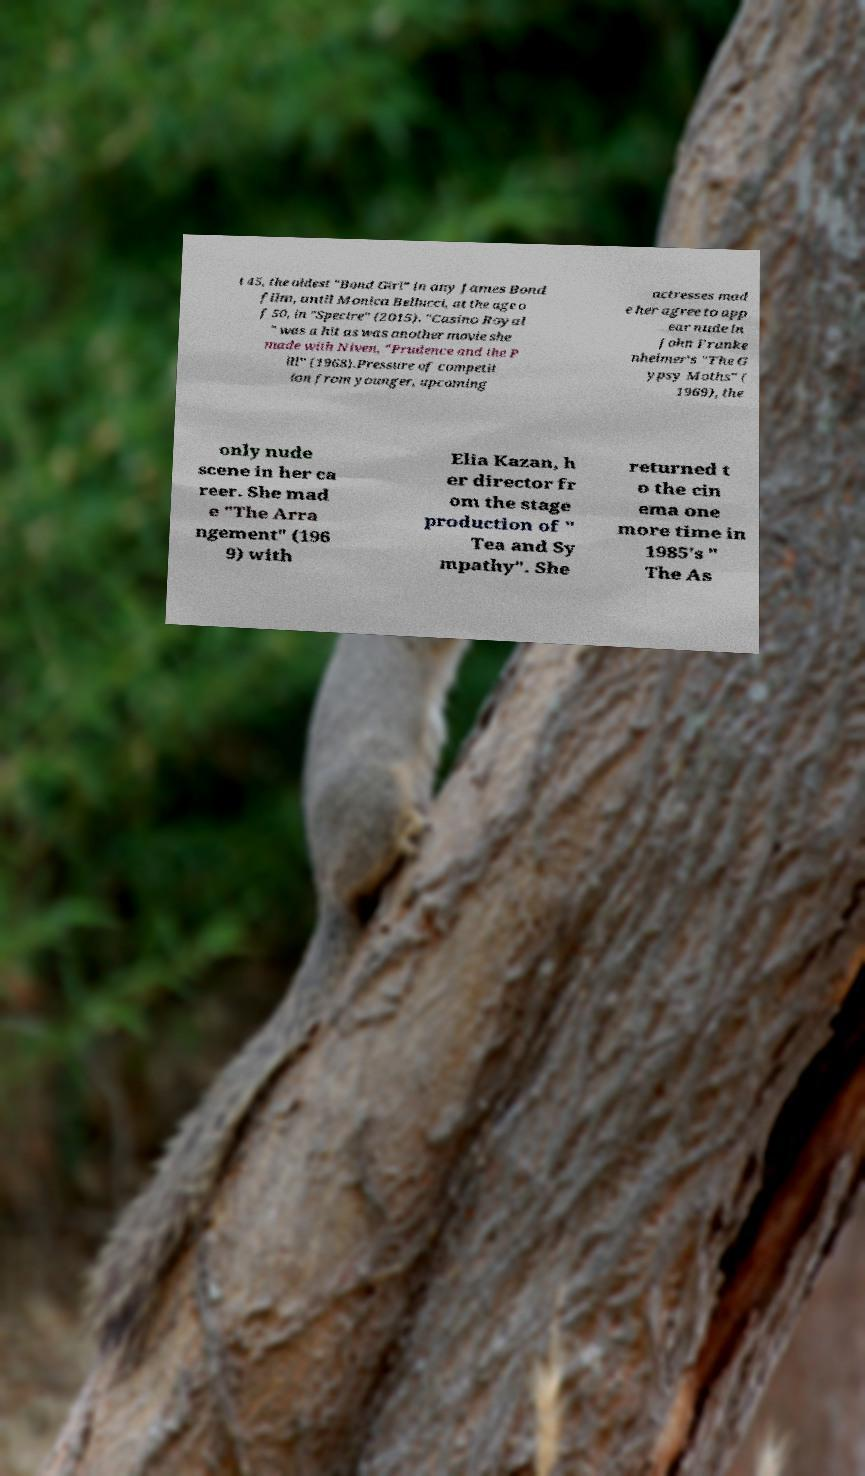Can you accurately transcribe the text from the provided image for me? t 45, the oldest "Bond Girl" in any James Bond film, until Monica Bellucci, at the age o f 50, in "Spectre" (2015). "Casino Royal " was a hit as was another movie she made with Niven, "Prudence and the P ill" (1968).Pressure of competit ion from younger, upcoming actresses mad e her agree to app ear nude in John Franke nheimer's "The G ypsy Moths" ( 1969), the only nude scene in her ca reer. She mad e "The Arra ngement" (196 9) with Elia Kazan, h er director fr om the stage production of " Tea and Sy mpathy". She returned t o the cin ema one more time in 1985's " The As 